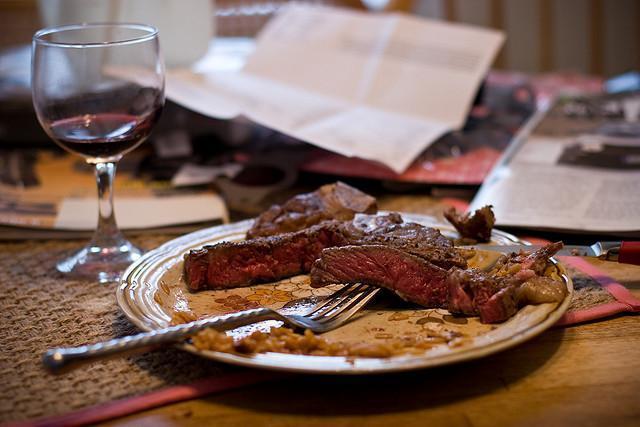How many forks are on the plate?
Give a very brief answer. 1. How many cows are visible?
Give a very brief answer. 0. 